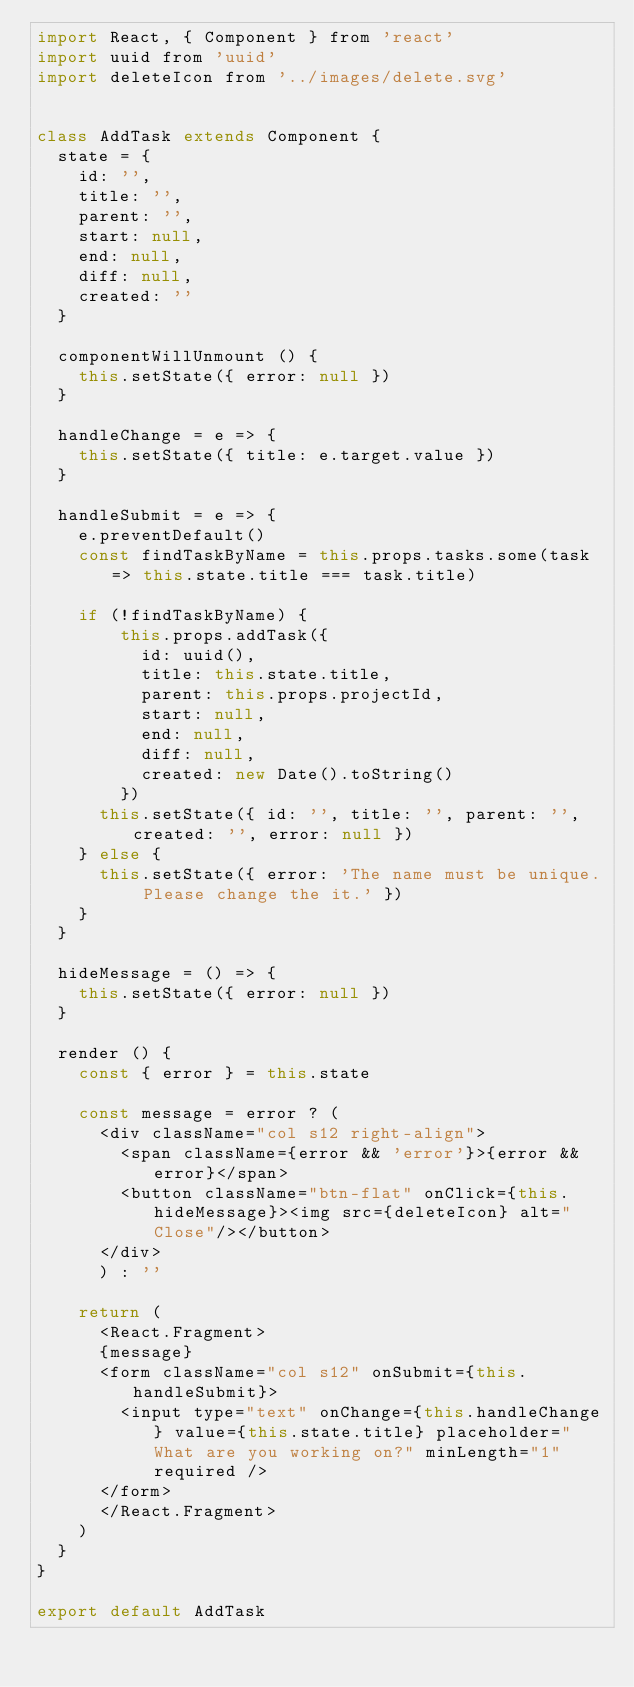<code> <loc_0><loc_0><loc_500><loc_500><_JavaScript_>import React, { Component } from 'react'
import uuid from 'uuid'
import deleteIcon from '../images/delete.svg'


class AddTask extends Component {
  state = {
    id: '',
    title: '',
    parent: '',
    start: null,
    end: null,
    diff: null,
    created: ''
  }

  componentWillUnmount () {
    this.setState({ error: null })
  }

  handleChange = e => {
    this.setState({ title: e.target.value })
  }

  handleSubmit = e => {
    e.preventDefault()
    const findTaskByName = this.props.tasks.some(task => this.state.title === task.title)

    if (!findTaskByName) {
        this.props.addTask({
          id: uuid(),
          title: this.state.title,
          parent: this.props.projectId,
          start: null,
          end: null,
          diff: null,
          created: new Date().toString()
        })
      this.setState({ id: '', title: '', parent: '', created: '', error: null })
    } else {
      this.setState({ error: 'The name must be unique. Please change the it.' })
    }
  }

  hideMessage = () => {
    this.setState({ error: null })
  }

  render () {
    const { error } = this.state
    
    const message = error ? (
      <div className="col s12 right-align">
        <span className={error && 'error'}>{error && error}</span>
        <button className="btn-flat" onClick={this.hideMessage}><img src={deleteIcon} alt="Close"/></button>
      </div>
      ) : ''

    return (
      <React.Fragment>
      {message}
      <form className="col s12" onSubmit={this.handleSubmit}>
        <input type="text" onChange={this.handleChange} value={this.state.title} placeholder="What are you working on?" minLength="1" required />
      </form>
      </React.Fragment>
    )
  }
}

export default AddTask
</code> 